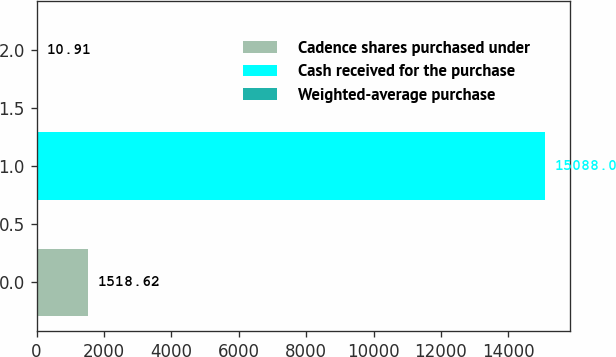Convert chart to OTSL. <chart><loc_0><loc_0><loc_500><loc_500><bar_chart><fcel>Cadence shares purchased under<fcel>Cash received for the purchase<fcel>Weighted-average purchase<nl><fcel>1518.62<fcel>15088<fcel>10.91<nl></chart> 